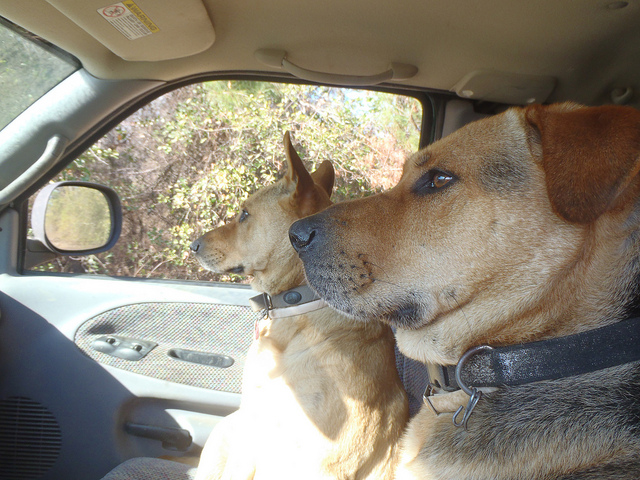How many dogs are in this scene? 2 